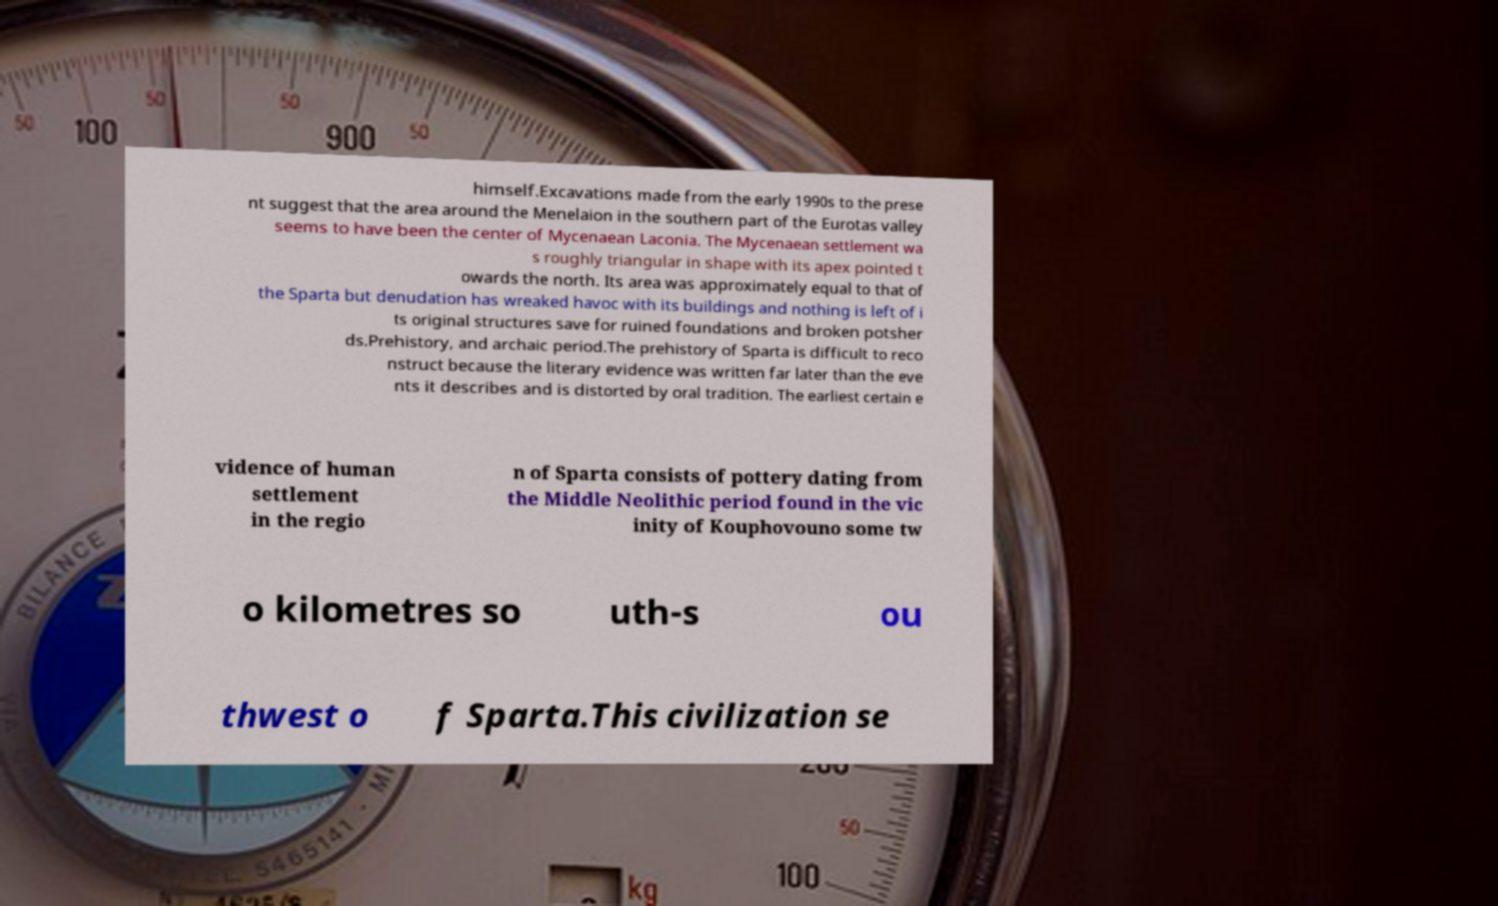Could you extract and type out the text from this image? himself.Excavations made from the early 1990s to the prese nt suggest that the area around the Menelaion in the southern part of the Eurotas valley seems to have been the center of Mycenaean Laconia. The Mycenaean settlement wa s roughly triangular in shape with its apex pointed t owards the north. Its area was approximately equal to that of the Sparta but denudation has wreaked havoc with its buildings and nothing is left of i ts original structures save for ruined foundations and broken potsher ds.Prehistory, and archaic period.The prehistory of Sparta is difficult to reco nstruct because the literary evidence was written far later than the eve nts it describes and is distorted by oral tradition. The earliest certain e vidence of human settlement in the regio n of Sparta consists of pottery dating from the Middle Neolithic period found in the vic inity of Kouphovouno some tw o kilometres so uth-s ou thwest o f Sparta.This civilization se 